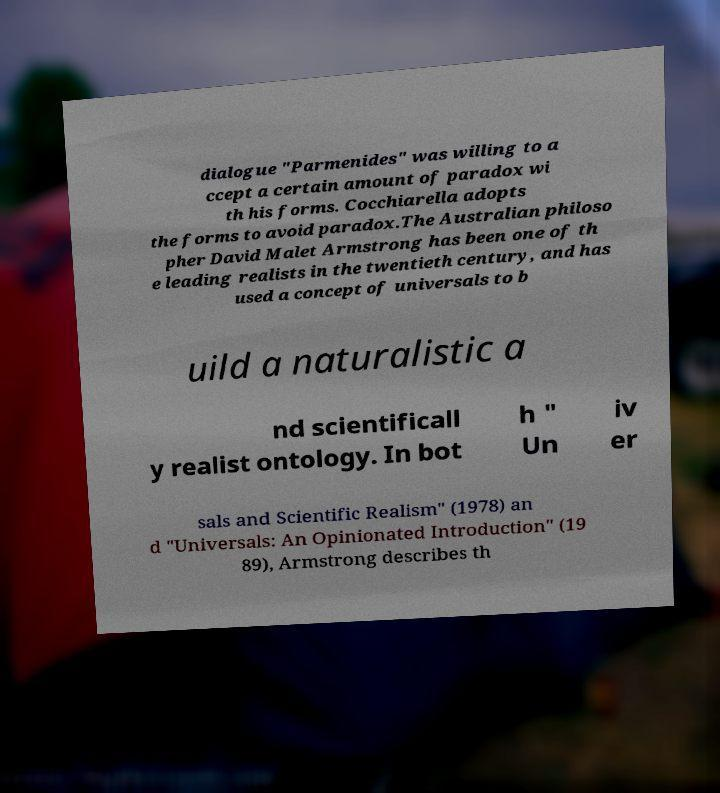For documentation purposes, I need the text within this image transcribed. Could you provide that? dialogue "Parmenides" was willing to a ccept a certain amount of paradox wi th his forms. Cocchiarella adopts the forms to avoid paradox.The Australian philoso pher David Malet Armstrong has been one of th e leading realists in the twentieth century, and has used a concept of universals to b uild a naturalistic a nd scientificall y realist ontology. In bot h " Un iv er sals and Scientific Realism" (1978) an d "Universals: An Opinionated Introduction" (19 89), Armstrong describes th 